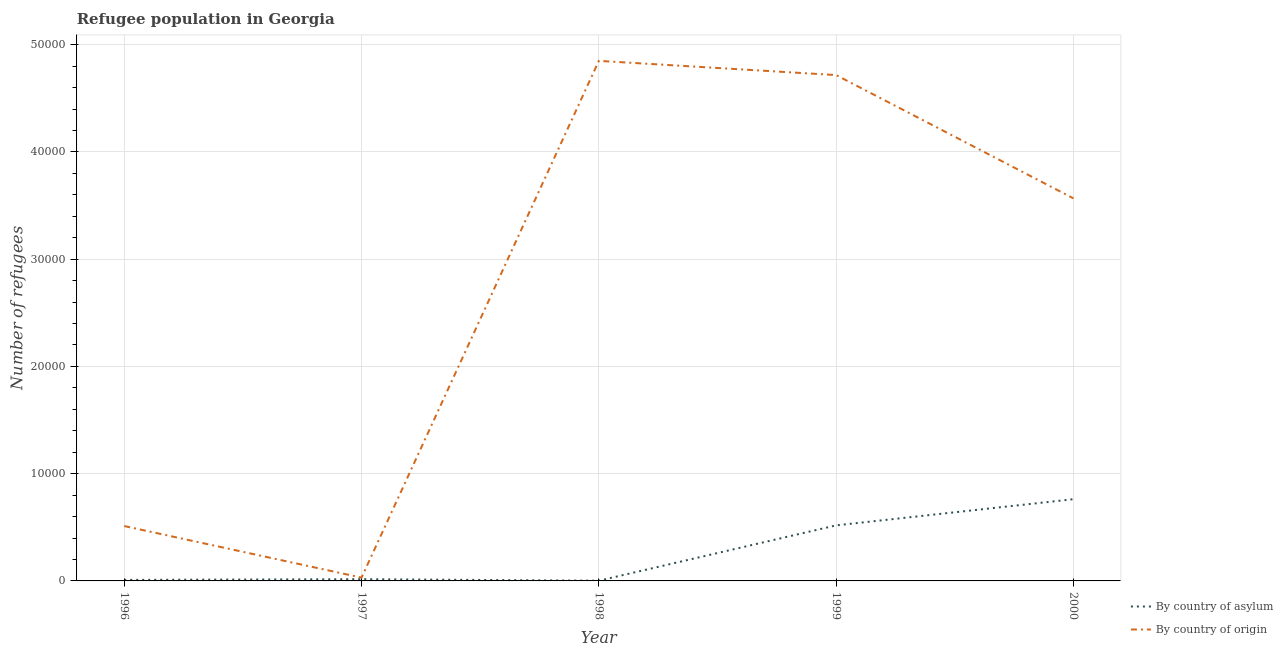Is the number of lines equal to the number of legend labels?
Keep it short and to the point. Yes. What is the number of refugees by country of origin in 2000?
Your answer should be compact. 3.57e+04. Across all years, what is the maximum number of refugees by country of asylum?
Your response must be concise. 7620. Across all years, what is the minimum number of refugees by country of origin?
Offer a very short reply. 308. In which year was the number of refugees by country of origin maximum?
Give a very brief answer. 1998. What is the total number of refugees by country of asylum in the graph?
Provide a succinct answer. 1.31e+04. What is the difference between the number of refugees by country of origin in 1996 and that in 1999?
Give a very brief answer. -4.20e+04. What is the difference between the number of refugees by country of origin in 1998 and the number of refugees by country of asylum in 1999?
Your answer should be very brief. 4.33e+04. What is the average number of refugees by country of asylum per year?
Make the answer very short. 2615.4. In the year 1999, what is the difference between the number of refugees by country of asylum and number of refugees by country of origin?
Provide a succinct answer. -4.20e+04. In how many years, is the number of refugees by country of origin greater than 6000?
Provide a succinct answer. 3. What is the ratio of the number of refugees by country of origin in 1997 to that in 1999?
Offer a terse response. 0.01. What is the difference between the highest and the second highest number of refugees by country of asylum?
Keep it short and to the point. 2440. What is the difference between the highest and the lowest number of refugees by country of origin?
Offer a very short reply. 4.82e+04. Is the sum of the number of refugees by country of asylum in 1996 and 1999 greater than the maximum number of refugees by country of origin across all years?
Give a very brief answer. No. Does the graph contain any zero values?
Provide a short and direct response. No. Does the graph contain grids?
Offer a terse response. Yes. How many legend labels are there?
Your answer should be compact. 2. What is the title of the graph?
Offer a very short reply. Refugee population in Georgia. Does "Start a business" appear as one of the legend labels in the graph?
Make the answer very short. No. What is the label or title of the X-axis?
Provide a succinct answer. Year. What is the label or title of the Y-axis?
Offer a very short reply. Number of refugees. What is the Number of refugees of By country of asylum in 1996?
Give a very brief answer. 95. What is the Number of refugees of By country of origin in 1996?
Give a very brief answer. 5117. What is the Number of refugees of By country of asylum in 1997?
Your answer should be compact. 162. What is the Number of refugees of By country of origin in 1997?
Give a very brief answer. 308. What is the Number of refugees of By country of asylum in 1998?
Offer a terse response. 20. What is the Number of refugees of By country of origin in 1998?
Keep it short and to the point. 4.85e+04. What is the Number of refugees of By country of asylum in 1999?
Make the answer very short. 5180. What is the Number of refugees of By country of origin in 1999?
Your response must be concise. 4.72e+04. What is the Number of refugees in By country of asylum in 2000?
Your answer should be compact. 7620. What is the Number of refugees of By country of origin in 2000?
Provide a short and direct response. 3.57e+04. Across all years, what is the maximum Number of refugees of By country of asylum?
Your answer should be very brief. 7620. Across all years, what is the maximum Number of refugees in By country of origin?
Your answer should be compact. 4.85e+04. Across all years, what is the minimum Number of refugees of By country of origin?
Offer a terse response. 308. What is the total Number of refugees of By country of asylum in the graph?
Give a very brief answer. 1.31e+04. What is the total Number of refugees of By country of origin in the graph?
Make the answer very short. 1.37e+05. What is the difference between the Number of refugees in By country of asylum in 1996 and that in 1997?
Ensure brevity in your answer.  -67. What is the difference between the Number of refugees of By country of origin in 1996 and that in 1997?
Give a very brief answer. 4809. What is the difference between the Number of refugees of By country of origin in 1996 and that in 1998?
Your response must be concise. -4.34e+04. What is the difference between the Number of refugees in By country of asylum in 1996 and that in 1999?
Provide a succinct answer. -5085. What is the difference between the Number of refugees of By country of origin in 1996 and that in 1999?
Give a very brief answer. -4.20e+04. What is the difference between the Number of refugees of By country of asylum in 1996 and that in 2000?
Offer a very short reply. -7525. What is the difference between the Number of refugees in By country of origin in 1996 and that in 2000?
Offer a very short reply. -3.06e+04. What is the difference between the Number of refugees of By country of asylum in 1997 and that in 1998?
Keep it short and to the point. 142. What is the difference between the Number of refugees of By country of origin in 1997 and that in 1998?
Offer a terse response. -4.82e+04. What is the difference between the Number of refugees in By country of asylum in 1997 and that in 1999?
Make the answer very short. -5018. What is the difference between the Number of refugees in By country of origin in 1997 and that in 1999?
Ensure brevity in your answer.  -4.69e+04. What is the difference between the Number of refugees in By country of asylum in 1997 and that in 2000?
Provide a short and direct response. -7458. What is the difference between the Number of refugees of By country of origin in 1997 and that in 2000?
Give a very brief answer. -3.54e+04. What is the difference between the Number of refugees in By country of asylum in 1998 and that in 1999?
Your answer should be very brief. -5160. What is the difference between the Number of refugees in By country of origin in 1998 and that in 1999?
Provide a succinct answer. 1325. What is the difference between the Number of refugees of By country of asylum in 1998 and that in 2000?
Provide a short and direct response. -7600. What is the difference between the Number of refugees in By country of origin in 1998 and that in 2000?
Your answer should be compact. 1.28e+04. What is the difference between the Number of refugees of By country of asylum in 1999 and that in 2000?
Ensure brevity in your answer.  -2440. What is the difference between the Number of refugees of By country of origin in 1999 and that in 2000?
Provide a succinct answer. 1.15e+04. What is the difference between the Number of refugees of By country of asylum in 1996 and the Number of refugees of By country of origin in 1997?
Your answer should be very brief. -213. What is the difference between the Number of refugees in By country of asylum in 1996 and the Number of refugees in By country of origin in 1998?
Give a very brief answer. -4.84e+04. What is the difference between the Number of refugees of By country of asylum in 1996 and the Number of refugees of By country of origin in 1999?
Ensure brevity in your answer.  -4.71e+04. What is the difference between the Number of refugees of By country of asylum in 1996 and the Number of refugees of By country of origin in 2000?
Make the answer very short. -3.56e+04. What is the difference between the Number of refugees in By country of asylum in 1997 and the Number of refugees in By country of origin in 1998?
Your answer should be compact. -4.83e+04. What is the difference between the Number of refugees in By country of asylum in 1997 and the Number of refugees in By country of origin in 1999?
Provide a succinct answer. -4.70e+04. What is the difference between the Number of refugees in By country of asylum in 1997 and the Number of refugees in By country of origin in 2000?
Provide a succinct answer. -3.55e+04. What is the difference between the Number of refugees of By country of asylum in 1998 and the Number of refugees of By country of origin in 1999?
Give a very brief answer. -4.71e+04. What is the difference between the Number of refugees in By country of asylum in 1998 and the Number of refugees in By country of origin in 2000?
Provide a short and direct response. -3.56e+04. What is the difference between the Number of refugees in By country of asylum in 1999 and the Number of refugees in By country of origin in 2000?
Provide a succinct answer. -3.05e+04. What is the average Number of refugees of By country of asylum per year?
Offer a very short reply. 2615.4. What is the average Number of refugees of By country of origin per year?
Your answer should be very brief. 2.73e+04. In the year 1996, what is the difference between the Number of refugees of By country of asylum and Number of refugees of By country of origin?
Your response must be concise. -5022. In the year 1997, what is the difference between the Number of refugees in By country of asylum and Number of refugees in By country of origin?
Provide a short and direct response. -146. In the year 1998, what is the difference between the Number of refugees of By country of asylum and Number of refugees of By country of origin?
Your answer should be very brief. -4.85e+04. In the year 1999, what is the difference between the Number of refugees of By country of asylum and Number of refugees of By country of origin?
Your response must be concise. -4.20e+04. In the year 2000, what is the difference between the Number of refugees of By country of asylum and Number of refugees of By country of origin?
Ensure brevity in your answer.  -2.80e+04. What is the ratio of the Number of refugees of By country of asylum in 1996 to that in 1997?
Give a very brief answer. 0.59. What is the ratio of the Number of refugees in By country of origin in 1996 to that in 1997?
Your answer should be very brief. 16.61. What is the ratio of the Number of refugees in By country of asylum in 1996 to that in 1998?
Offer a very short reply. 4.75. What is the ratio of the Number of refugees of By country of origin in 1996 to that in 1998?
Make the answer very short. 0.11. What is the ratio of the Number of refugees in By country of asylum in 1996 to that in 1999?
Your response must be concise. 0.02. What is the ratio of the Number of refugees in By country of origin in 1996 to that in 1999?
Ensure brevity in your answer.  0.11. What is the ratio of the Number of refugees in By country of asylum in 1996 to that in 2000?
Make the answer very short. 0.01. What is the ratio of the Number of refugees in By country of origin in 1996 to that in 2000?
Ensure brevity in your answer.  0.14. What is the ratio of the Number of refugees in By country of asylum in 1997 to that in 1998?
Offer a terse response. 8.1. What is the ratio of the Number of refugees in By country of origin in 1997 to that in 1998?
Keep it short and to the point. 0.01. What is the ratio of the Number of refugees in By country of asylum in 1997 to that in 1999?
Offer a very short reply. 0.03. What is the ratio of the Number of refugees in By country of origin in 1997 to that in 1999?
Give a very brief answer. 0.01. What is the ratio of the Number of refugees in By country of asylum in 1997 to that in 2000?
Keep it short and to the point. 0.02. What is the ratio of the Number of refugees in By country of origin in 1997 to that in 2000?
Give a very brief answer. 0.01. What is the ratio of the Number of refugees of By country of asylum in 1998 to that in 1999?
Your answer should be compact. 0. What is the ratio of the Number of refugees in By country of origin in 1998 to that in 1999?
Offer a very short reply. 1.03. What is the ratio of the Number of refugees of By country of asylum in 1998 to that in 2000?
Your answer should be very brief. 0. What is the ratio of the Number of refugees in By country of origin in 1998 to that in 2000?
Make the answer very short. 1.36. What is the ratio of the Number of refugees of By country of asylum in 1999 to that in 2000?
Your answer should be very brief. 0.68. What is the ratio of the Number of refugees in By country of origin in 1999 to that in 2000?
Your answer should be compact. 1.32. What is the difference between the highest and the second highest Number of refugees of By country of asylum?
Offer a terse response. 2440. What is the difference between the highest and the second highest Number of refugees in By country of origin?
Make the answer very short. 1325. What is the difference between the highest and the lowest Number of refugees of By country of asylum?
Ensure brevity in your answer.  7600. What is the difference between the highest and the lowest Number of refugees of By country of origin?
Your response must be concise. 4.82e+04. 